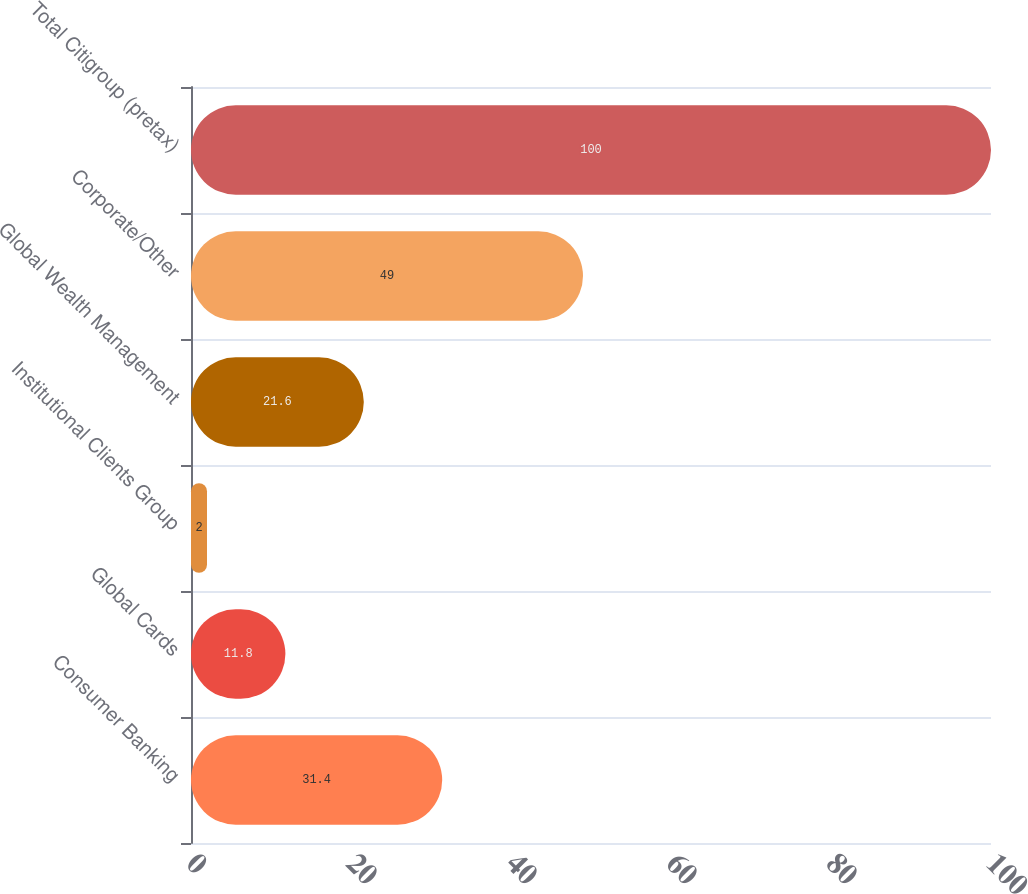Convert chart to OTSL. <chart><loc_0><loc_0><loc_500><loc_500><bar_chart><fcel>Consumer Banking<fcel>Global Cards<fcel>Institutional Clients Group<fcel>Global Wealth Management<fcel>Corporate/Other<fcel>Total Citigroup (pretax)<nl><fcel>31.4<fcel>11.8<fcel>2<fcel>21.6<fcel>49<fcel>100<nl></chart> 